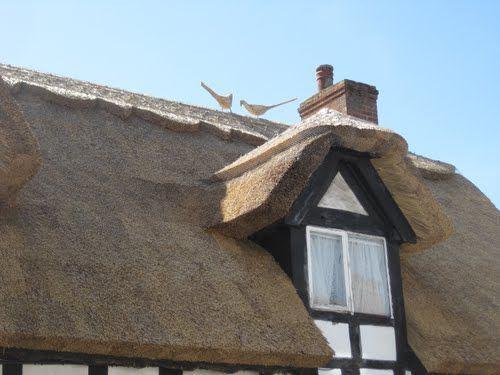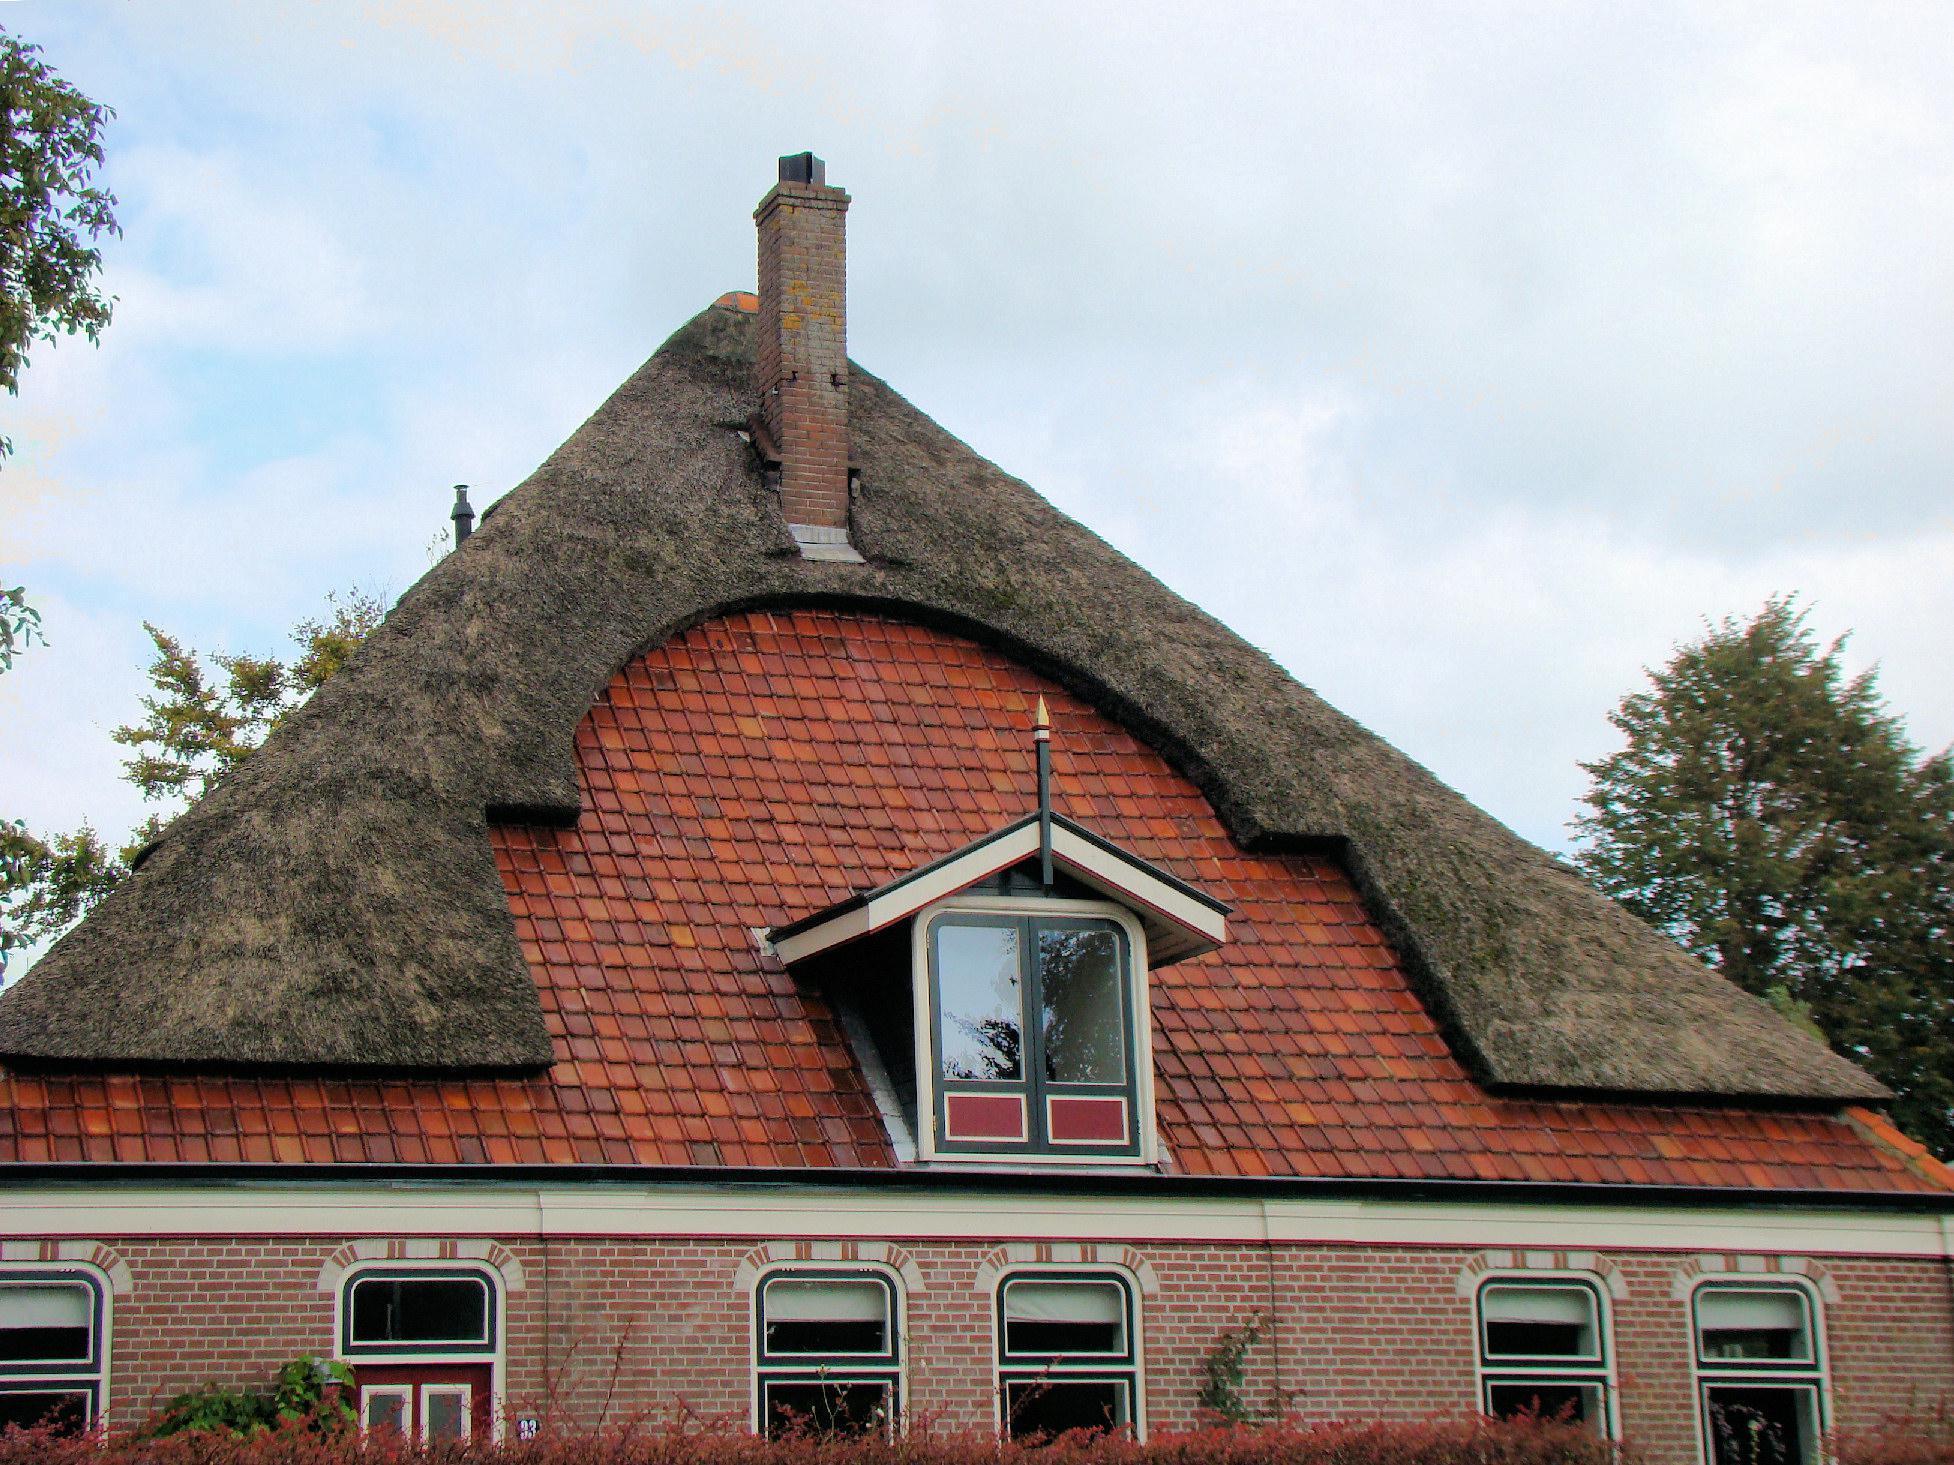The first image is the image on the left, the second image is the image on the right. Considering the images on both sides, is "The right image shows the peaked front of a building with a thatched roof that curves around at least one dormer window extending out of the upper front of the house." valid? Answer yes or no. Yes. The first image is the image on the left, the second image is the image on the right. Examine the images to the left and right. Is the description "A road is seen to the left of the building in one image and not in the other." accurate? Answer yes or no. No. 